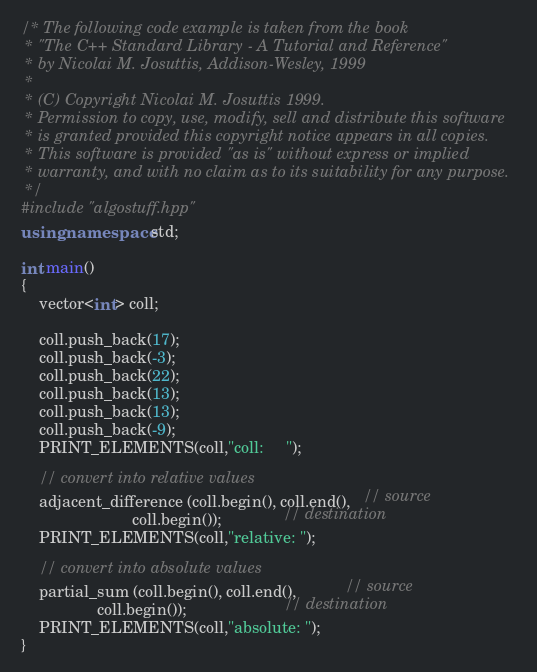<code> <loc_0><loc_0><loc_500><loc_500><_C++_>/* The following code example is taken from the book
 * "The C++ Standard Library - A Tutorial and Reference"
 * by Nicolai M. Josuttis, Addison-Wesley, 1999
 *
 * (C) Copyright Nicolai M. Josuttis 1999.
 * Permission to copy, use, modify, sell and distribute this software
 * is granted provided this copyright notice appears in all copies.
 * This software is provided "as is" without express or implied
 * warranty, and with no claim as to its suitability for any purpose.
 */
#include "algostuff.hpp"
using namespace std;

int main()
{
    vector<int> coll;

    coll.push_back(17);
    coll.push_back(-3);
    coll.push_back(22);
    coll.push_back(13);
    coll.push_back(13);
    coll.push_back(-9);
    PRINT_ELEMENTS(coll,"coll:     ");

    // convert into relative values
    adjacent_difference (coll.begin(), coll.end(),   // source
                         coll.begin());              // destination
    PRINT_ELEMENTS(coll,"relative: ");
     
    // convert into absolute values
    partial_sum (coll.begin(), coll.end(),           // source
                 coll.begin());                      // destination
    PRINT_ELEMENTS(coll,"absolute: ");
}
</code> 